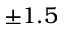<formula> <loc_0><loc_0><loc_500><loc_500>\pm 1 . 5</formula> 